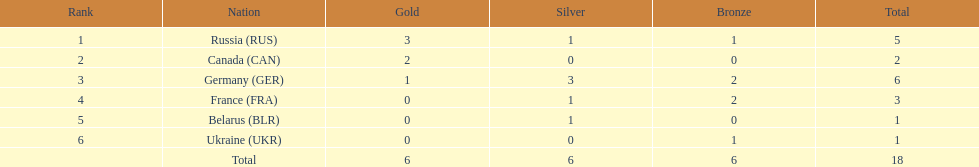What is the combined total of silver medals won by french and german competitors in the 1994 winter olympic biathlon? 4. 